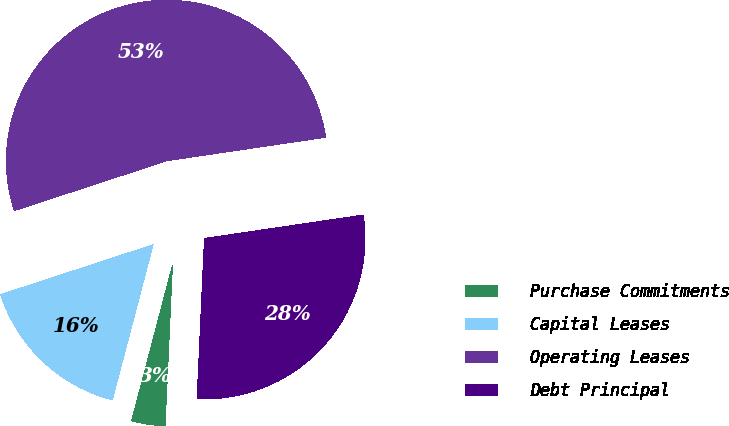Convert chart to OTSL. <chart><loc_0><loc_0><loc_500><loc_500><pie_chart><fcel>Purchase Commitments<fcel>Capital Leases<fcel>Operating Leases<fcel>Debt Principal<nl><fcel>3.36%<fcel>15.88%<fcel>52.7%<fcel>28.06%<nl></chart> 